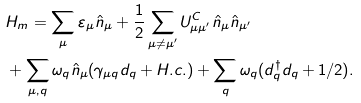Convert formula to latex. <formula><loc_0><loc_0><loc_500><loc_500>& H _ { m } = \sum _ { \mu } \varepsilon _ { \mu } \hat { n } _ { \mu } + \frac { 1 } { 2 } \sum _ { \mu \neq \mu ^ { \prime } } U _ { \mu \mu ^ { \prime } } ^ { C } \hat { n } _ { \mu } \hat { n } _ { \mu ^ { \prime } } \\ & + \sum _ { \mu , q } \omega _ { q } \hat { n } _ { \mu } ( \gamma _ { \mu q } d _ { q } + H . c . ) + \sum _ { q } \omega _ { q } ( d _ { q } ^ { \dagger } d _ { q } + 1 / 2 ) .</formula> 